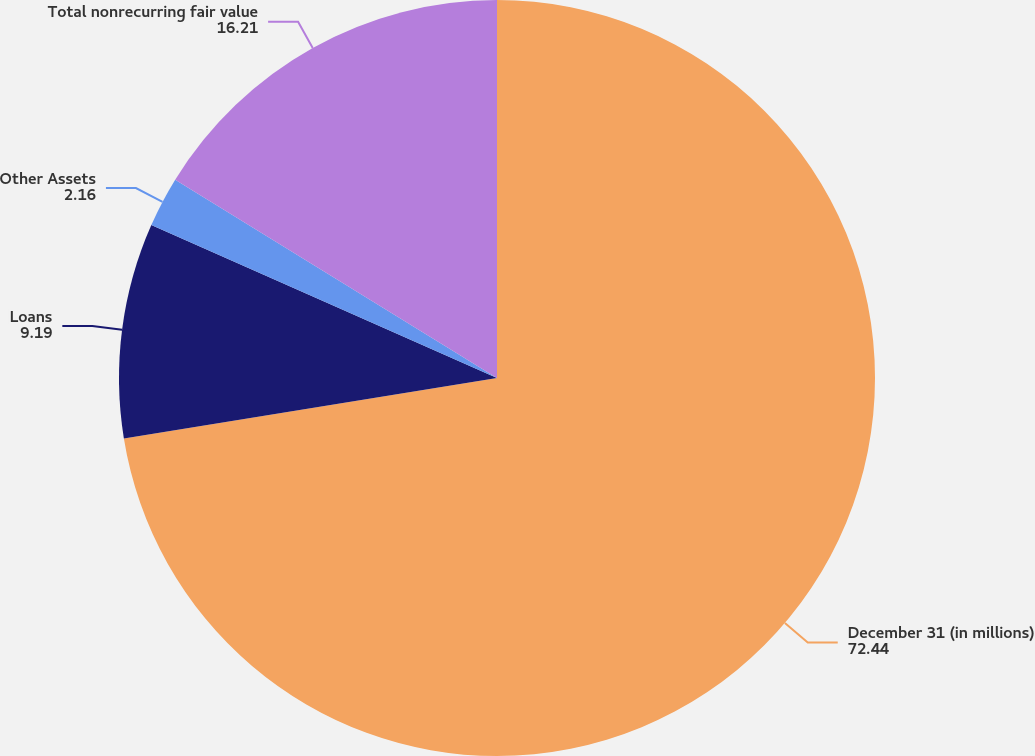Convert chart. <chart><loc_0><loc_0><loc_500><loc_500><pie_chart><fcel>December 31 (in millions)<fcel>Loans<fcel>Other Assets<fcel>Total nonrecurring fair value<nl><fcel>72.44%<fcel>9.19%<fcel>2.16%<fcel>16.21%<nl></chart> 